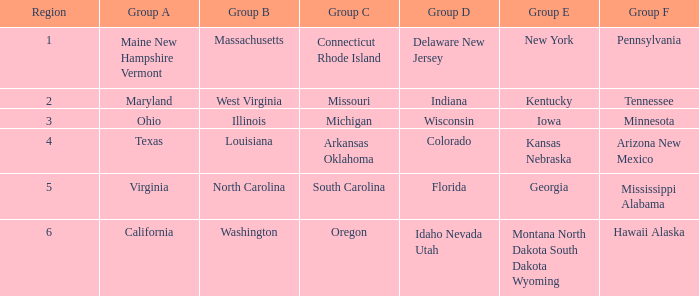What is the combined region consisting of a group b and a group e area in georgia? North Carolina. 